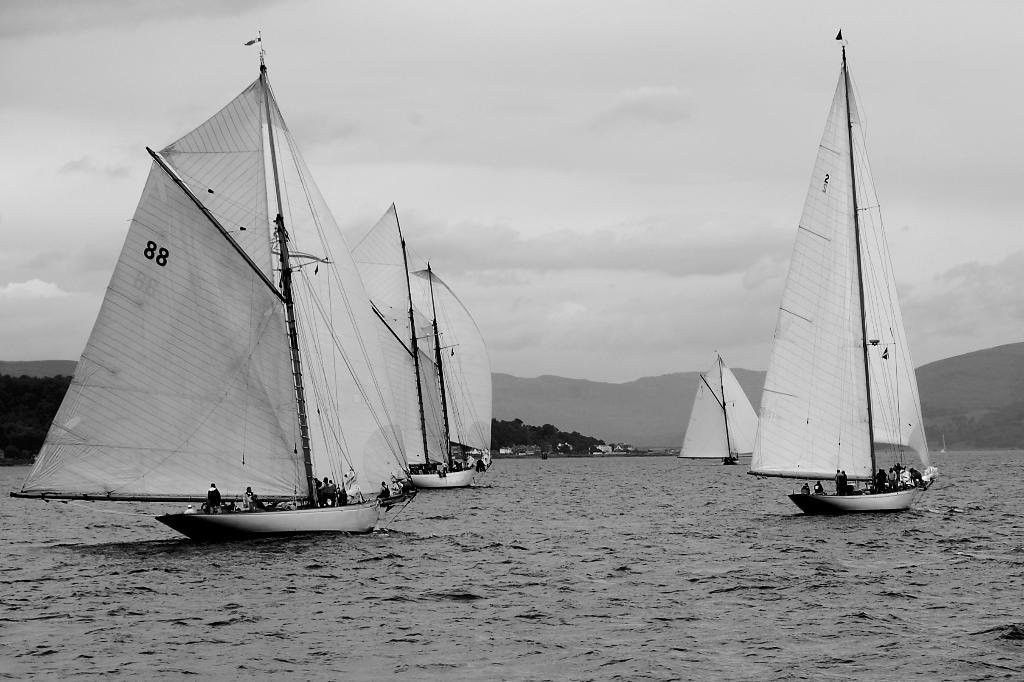What type of vehicles are in the water in the image? There are sailing ships in the water in the image. Are there any people on the ships? Yes, there are people in the ships. What can be seen in the background of the image? There are hills and trees in the background of the image. What is visible in the sky? There are clouds in the sky. What type of cake is being served on the sailing ships in the image? There is no cake present in the image; it features sailing ships with people on them. Can you tell me how many dinosaurs are visible in the image? There are no dinosaurs present in the image; it features sailing ships, people, hills, trees, and clouds. 